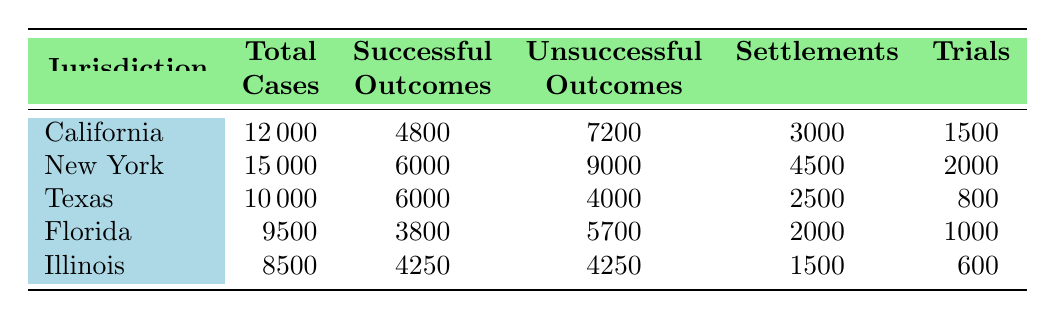How many total cases were reported in New York? In the table, under the New York entry, the number of total cases is clearly listed. It shows "Total Cases" as 15000.
Answer: 15000 What is the difference between successful and unsuccessful outcomes in Texas? In Texas, the successful outcomes are listed as 6000 and the unsuccessful outcomes as 4000. To find the difference, we subtract the unsuccessful from the successful: 6000 - 4000 = 2000.
Answer: 2000 Which jurisdiction had the highest number of settlements in 2022? By comparing the settlements across all jurisdictions, we can see that New York has the highest number at 4500, while the other jurisdictions have lower values.
Answer: New York What is the average number of trials across all jurisdictions? To find the average number of trials, we sum the values for trials in each jurisdiction: 1500 + 2000 + 800 + 1000 + 600 = 4900. Then we divide by the number of jurisdictions (5): 4900 / 5 = 980.
Answer: 980 Did Florida have more trials than Illinois? Florida has 1000 trials while Illinois has 600. Since 1000 is greater than 600, Florida indeed had more trials than Illinois.
Answer: Yes Which jurisdiction had the lowest successful outcomes, and how many were there? By examining the successful outcomes for each jurisdiction, we find that Florida has the lowest number at 3800, which is less than all other jurisdictions.
Answer: Florida, 3800 What percentage of cases in California were successful outcomes? In California, there were 4800 successful outcomes out of 12000 total cases. To find the percentage, we compute (4800 / 12000) * 100 = 40%.
Answer: 40% How many total unsuccessful outcomes were recorded in Florida and Illinois combined? The total unsuccessful outcomes for Florida is 5700 and for Illinois, it's 4250. We add these two values: 5700 + 4250 = 9950.
Answer: 9950 What is the ratio of successful outcomes to settlements in Texas? In Texas, there are 6000 successful outcomes and 2500 settlements. To find the ratio, we divide the successful outcomes by the settlements: 6000 / 2500 = 2.4.
Answer: 2.4 